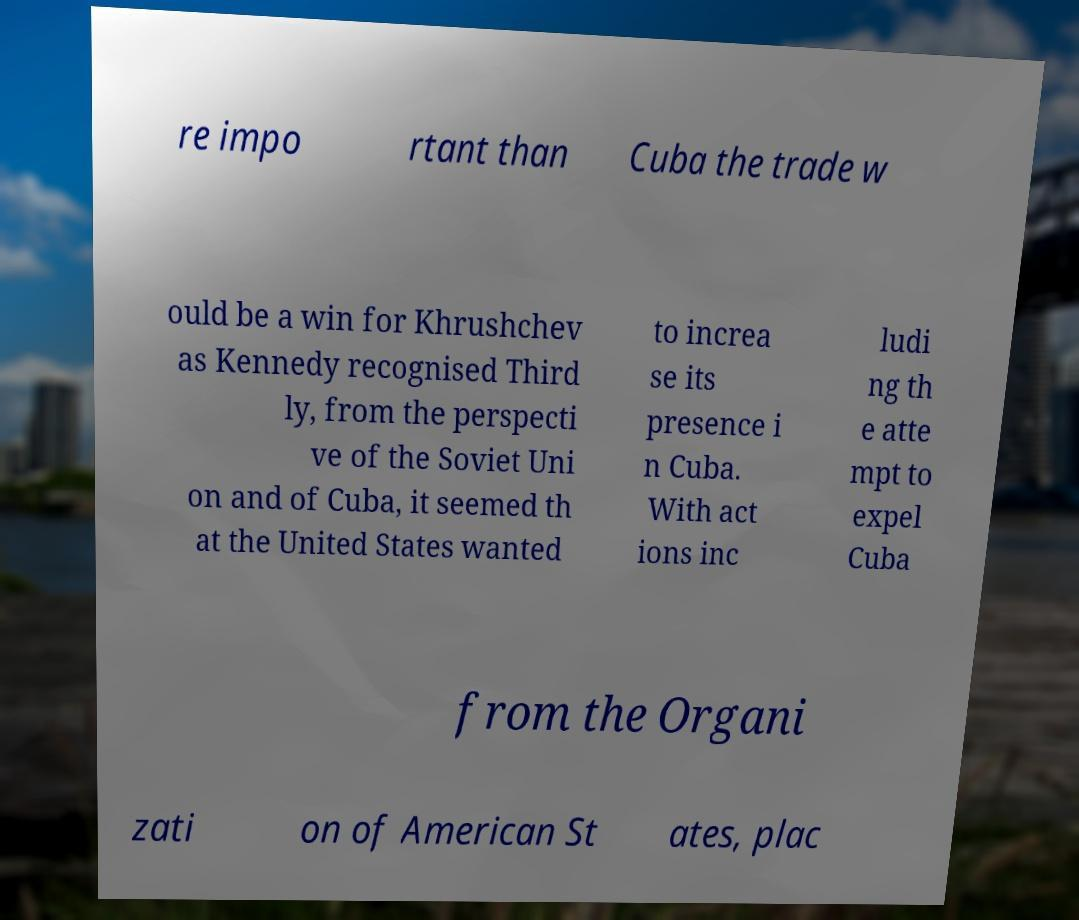Please read and relay the text visible in this image. What does it say? re impo rtant than Cuba the trade w ould be a win for Khrushchev as Kennedy recognised Third ly, from the perspecti ve of the Soviet Uni on and of Cuba, it seemed th at the United States wanted to increa se its presence i n Cuba. With act ions inc ludi ng th e atte mpt to expel Cuba from the Organi zati on of American St ates, plac 